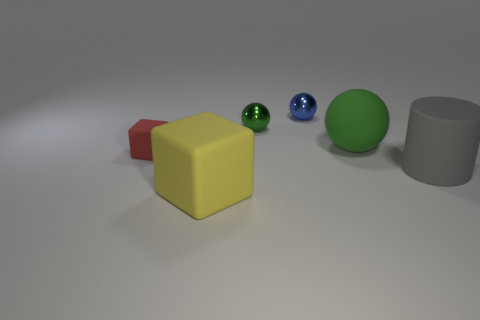Can you tell which object is closest to the light source? Based on the shadows, the green sphere appears to be the closest object to the light source, as it casts the darkest and sharpest shadow. The direction and length of shadows cast by each object can provide clues about their position relative to the light. 